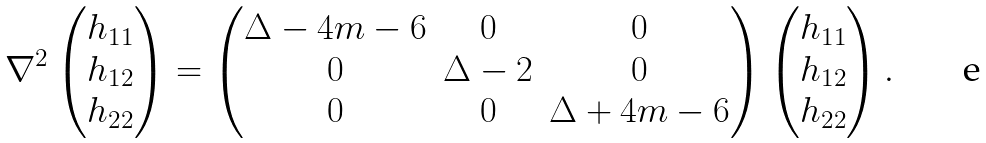<formula> <loc_0><loc_0><loc_500><loc_500>\nabla ^ { 2 } \begin{pmatrix} h _ { 1 1 } \\ h _ { 1 2 } \\ h _ { 2 2 } \end{pmatrix} = \begin{pmatrix} \Delta - 4 m - 6 & 0 & 0 \\ 0 & \Delta - 2 & 0 \\ 0 & 0 & \Delta + 4 m - 6 \end{pmatrix} \begin{pmatrix} h _ { 1 1 } \\ h _ { 1 2 } \\ h _ { 2 2 } \end{pmatrix} .</formula> 